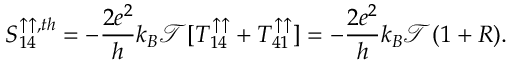<formula> <loc_0><loc_0><loc_500><loc_500>{ S _ { 1 4 } ^ { \uparrow \uparrow , t h } } = - \frac { 2 e ^ { 2 } } { h } k _ { B } \mathcal { T } [ T _ { 1 4 } ^ { \uparrow \uparrow } + T _ { 4 1 } ^ { \uparrow \uparrow } ] = - \frac { 2 e ^ { 2 } } { h } k _ { B } \mathcal { T } ( 1 + R ) .</formula> 